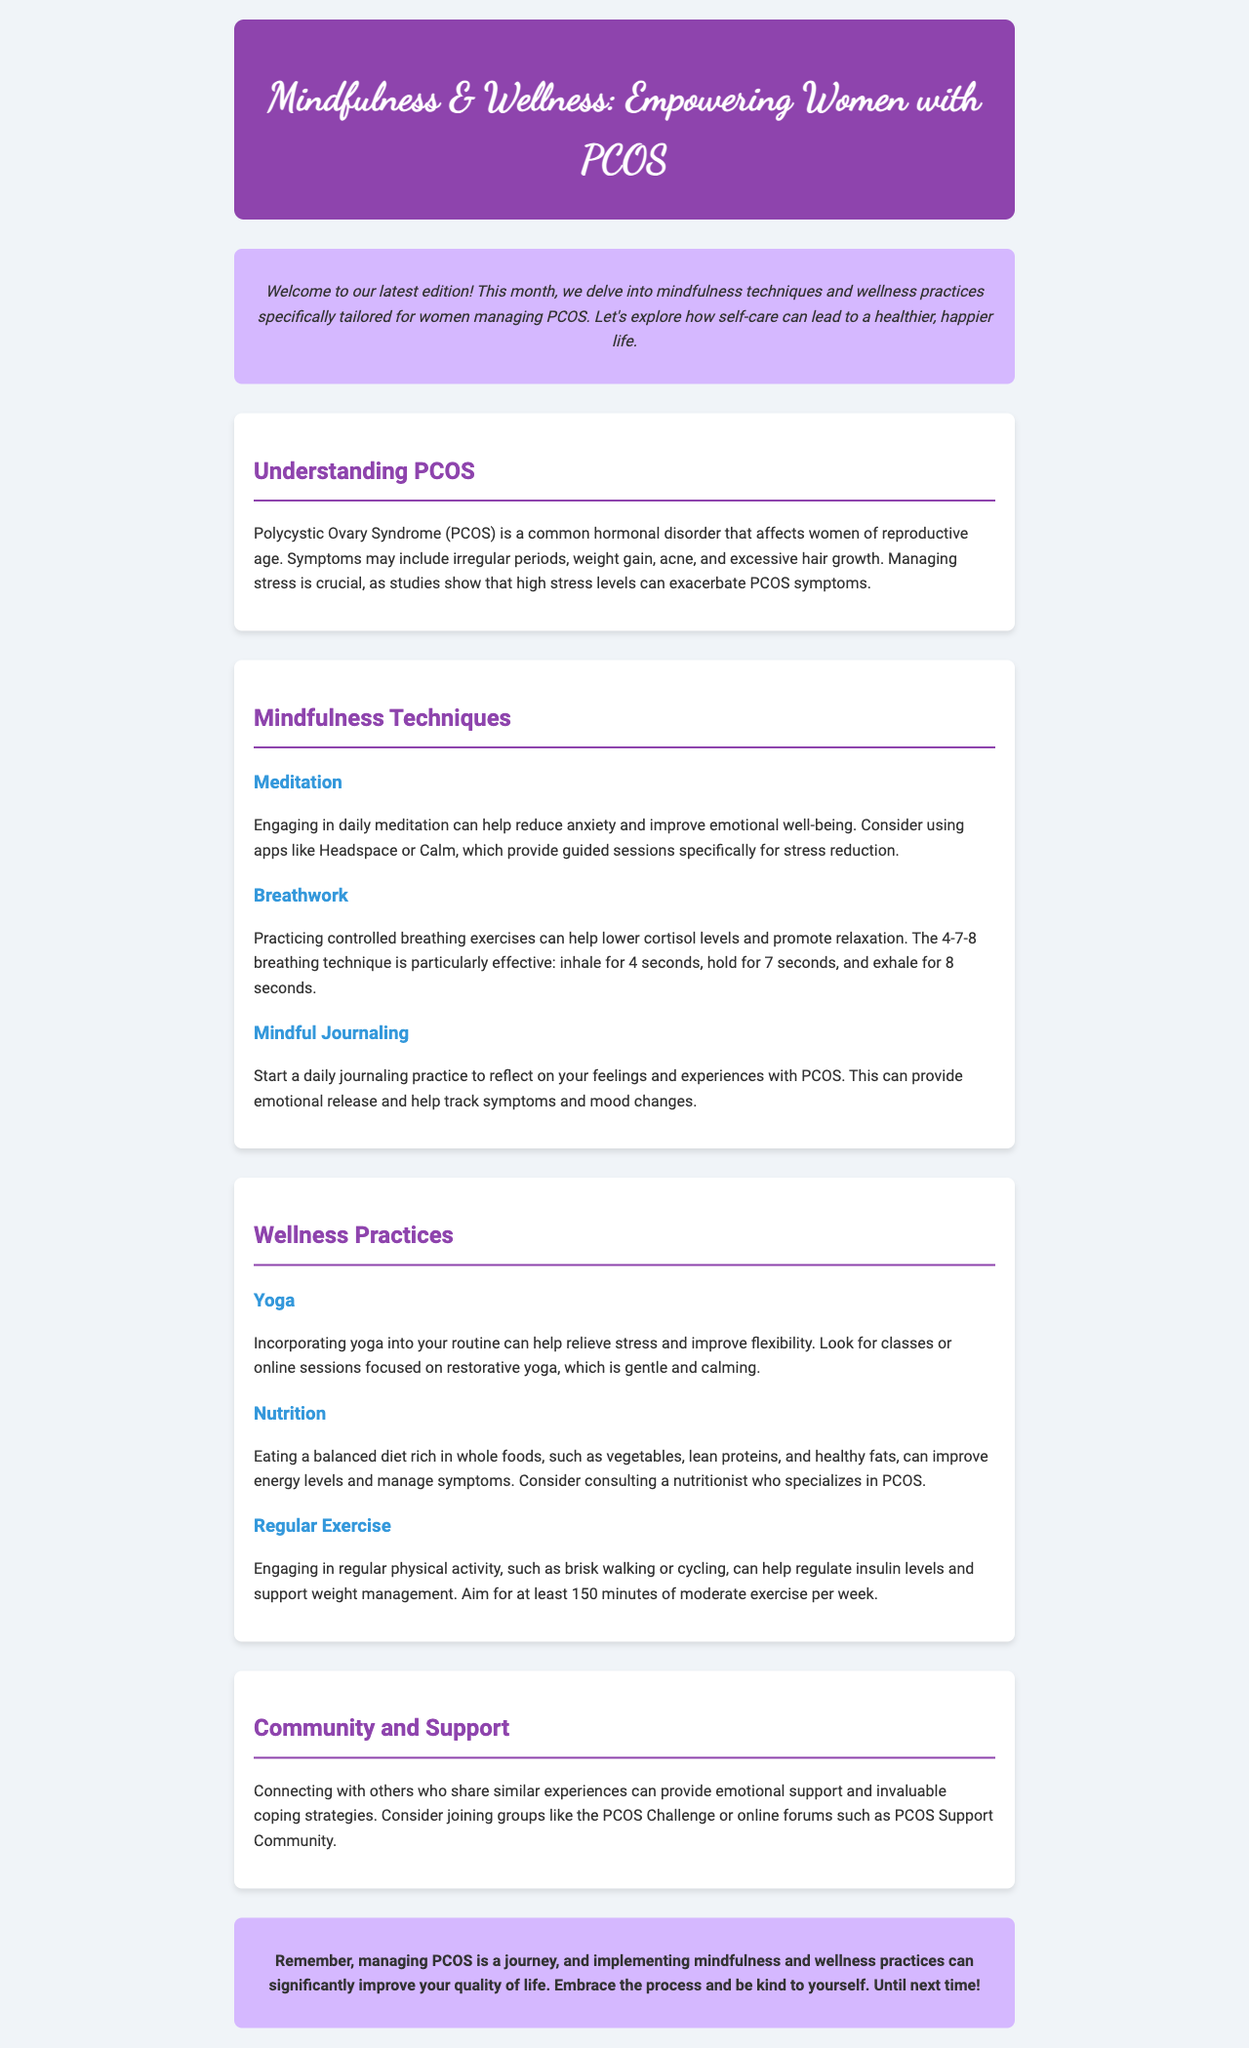What is the title of the newsletter? The title of the newsletter is prominently displayed in the header section of the document.
Answer: Mindfulness & Wellness: Empowering Women with PCOS How many mindfulness techniques are listed in the document? The section on mindfulness techniques provides three distinct methods for stress reduction.
Answer: 3 What is the first mindfulness technique mentioned? The first mindfulness technique listed is clearly stated in the appropriate section.
Answer: Meditation What type of exercise is recommended for women with PCOS? The wellness practices section suggests a type of physical activity beneficial for managing PCOS symptoms.
Answer: Regular Exercise Which app is suggested for meditation? The document recommends specific apps that provide guided meditation sessions focused on stress reduction.
Answer: Headspace What dietary approach is emphasized for managing PCOS? The nutrition section mentions the type of foods that should be included in a balanced diet for women with PCOS.
Answer: Whole foods What is the recommended weekly duration for regular exercise? The wellness practices section indicates the recommended amount of exercise for maintaining health.
Answer: 150 minutes Which community support group is mentioned? The community and support section highlights specific groups that offer help and connection for women with PCOS.
Answer: PCOS Challenge What color is used in the header background? The header's background color is mentioned in the styling aspect of the document, reflecting the newsletter's theme.
Answer: Purple 